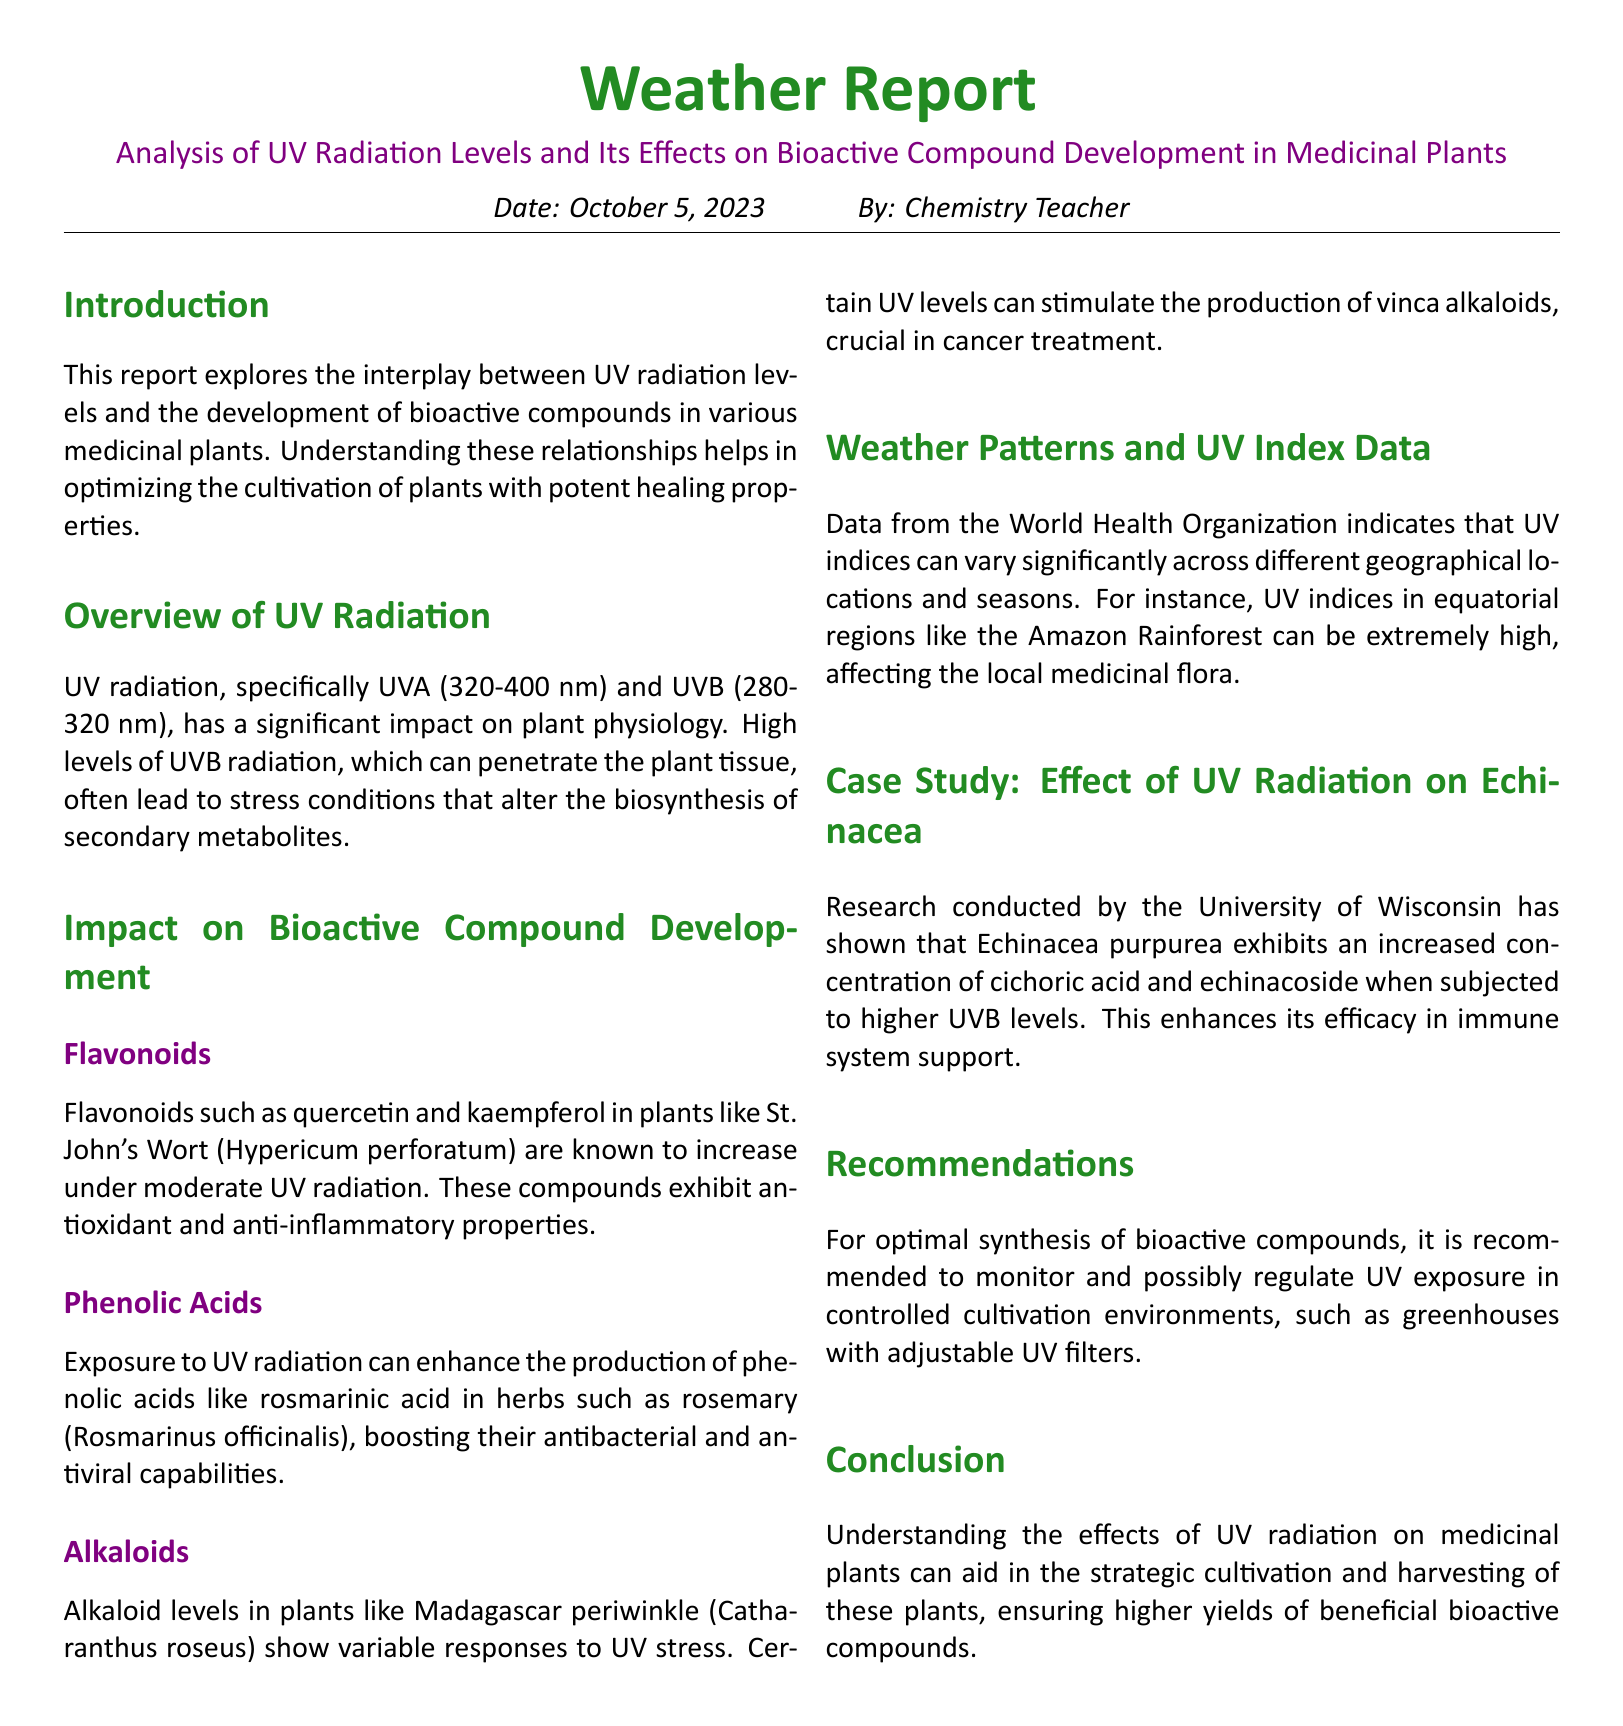What is the date of the report? The date of the report is stated in the introduction section, which is October 5, 2023.
Answer: October 5, 2023 Who is the author of the report? The author is mentioned at the top of the document, identifying as the Chemistry Teacher.
Answer: Chemistry Teacher What type of radiation is primarily discussed? The document focuses on UV radiation levels and their effects.
Answer: UV radiation Which plant's flavonoids are mentioned? The document specifically discusses flavonoids in St. John's Wort (Hypericum perforatum).
Answer: St. John's Wort What is the impact of UV radiation on Echinacea? It is noted that Echinacea purpurea shows increased concentrations of specific compounds when exposed to UVB levels.
Answer: Increased concentrations of cichoric acid and echinacoside What should be monitored to optimize bioactive compound synthesis? The document recommends monitoring UV exposure in controlled cultivation environments.
Answer: UV exposure Which specific phenolic acid is mentioned in relation to rosemary? The report states that rosmarinic acid production can be enhanced by UV exposure in rosemary.
Answer: Rosmarinic acid What is the main conclusion of the report? The conclusion emphasizes the importance of understanding UV radiation effects on the cultivation of beneficial medicinal plants.
Answer: Higher yields of beneficial bioactive compounds 